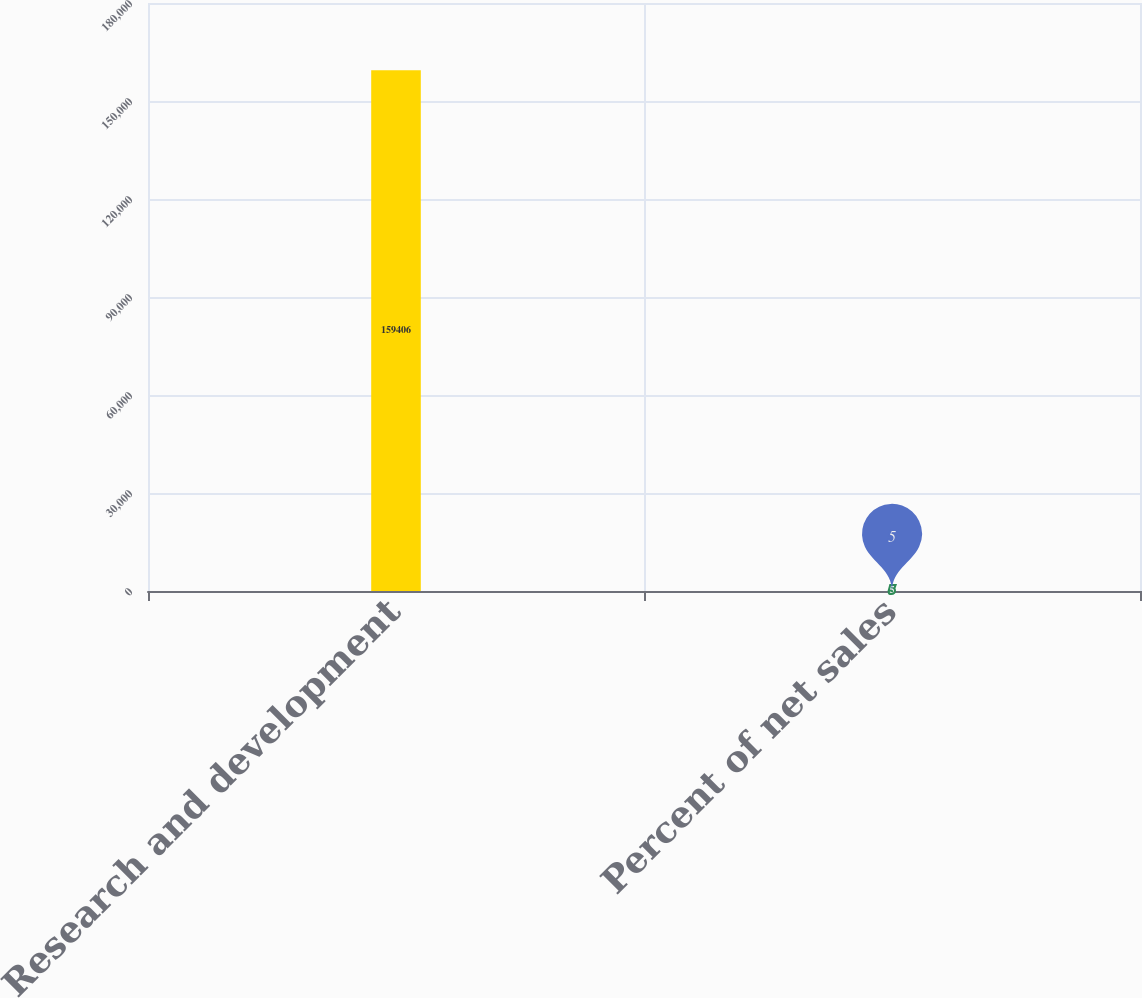<chart> <loc_0><loc_0><loc_500><loc_500><bar_chart><fcel>Research and development<fcel>Percent of net sales<nl><fcel>159406<fcel>5<nl></chart> 